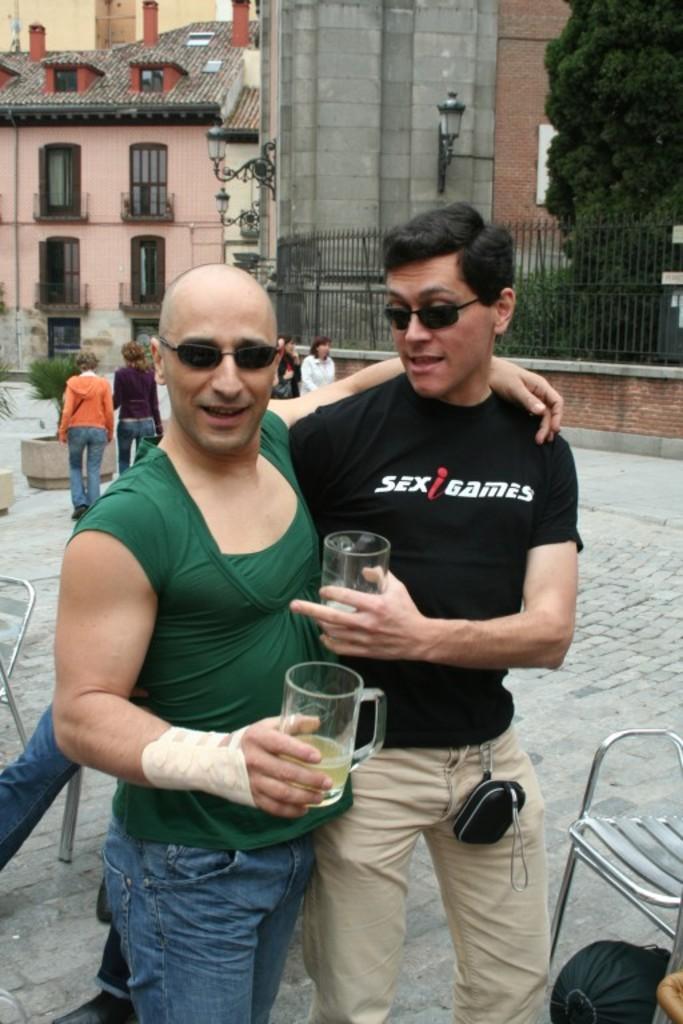How would you summarize this image in a sentence or two? In the image there is man in black t-shirt and cream pant standing in front of bald headed man in green t-shirt and jeans holding beer glasses and behind them there are buildings with people walking in front of it and trees inside fence on the right side. 